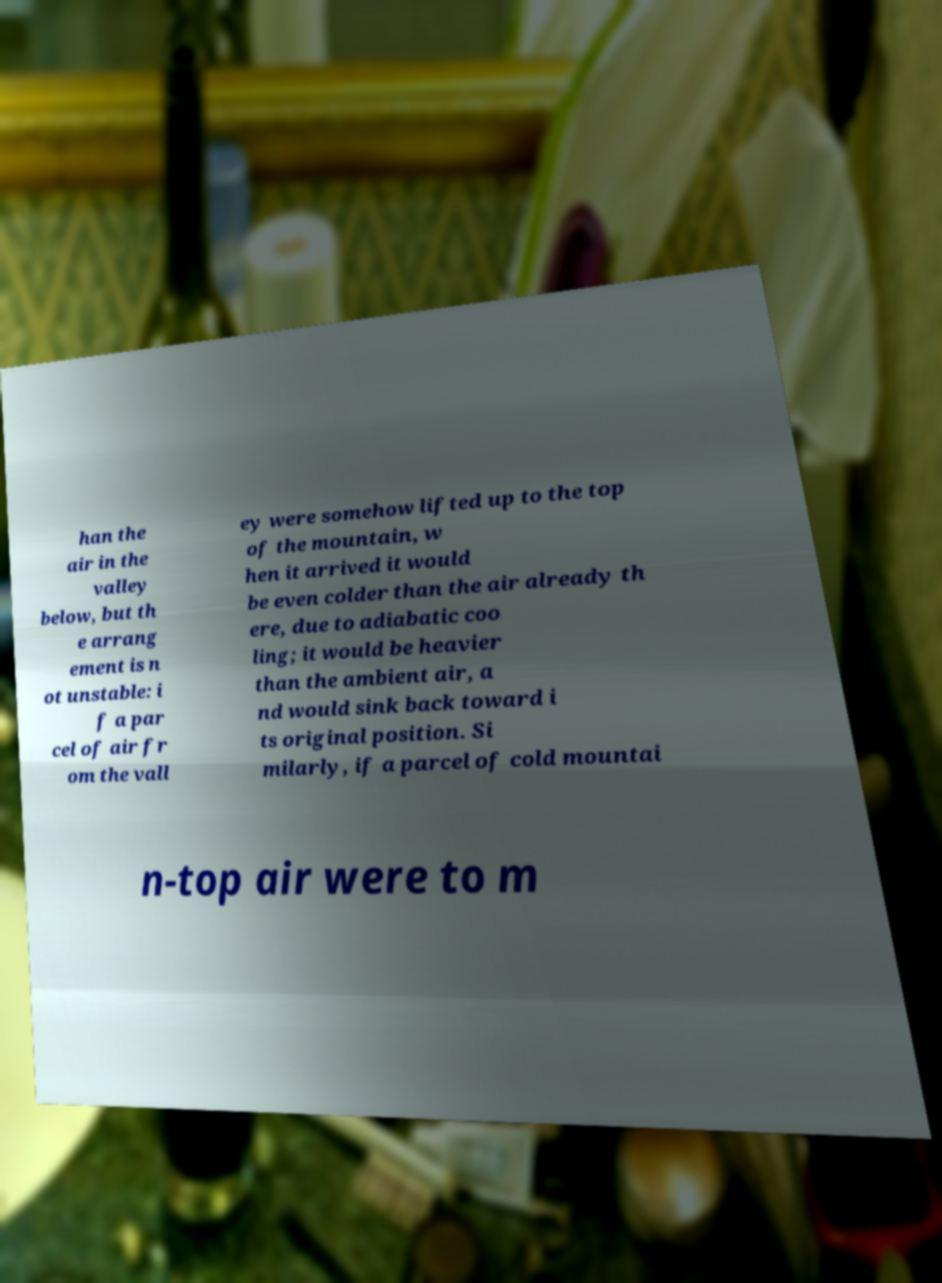What messages or text are displayed in this image? I need them in a readable, typed format. han the air in the valley below, but th e arrang ement is n ot unstable: i f a par cel of air fr om the vall ey were somehow lifted up to the top of the mountain, w hen it arrived it would be even colder than the air already th ere, due to adiabatic coo ling; it would be heavier than the ambient air, a nd would sink back toward i ts original position. Si milarly, if a parcel of cold mountai n-top air were to m 